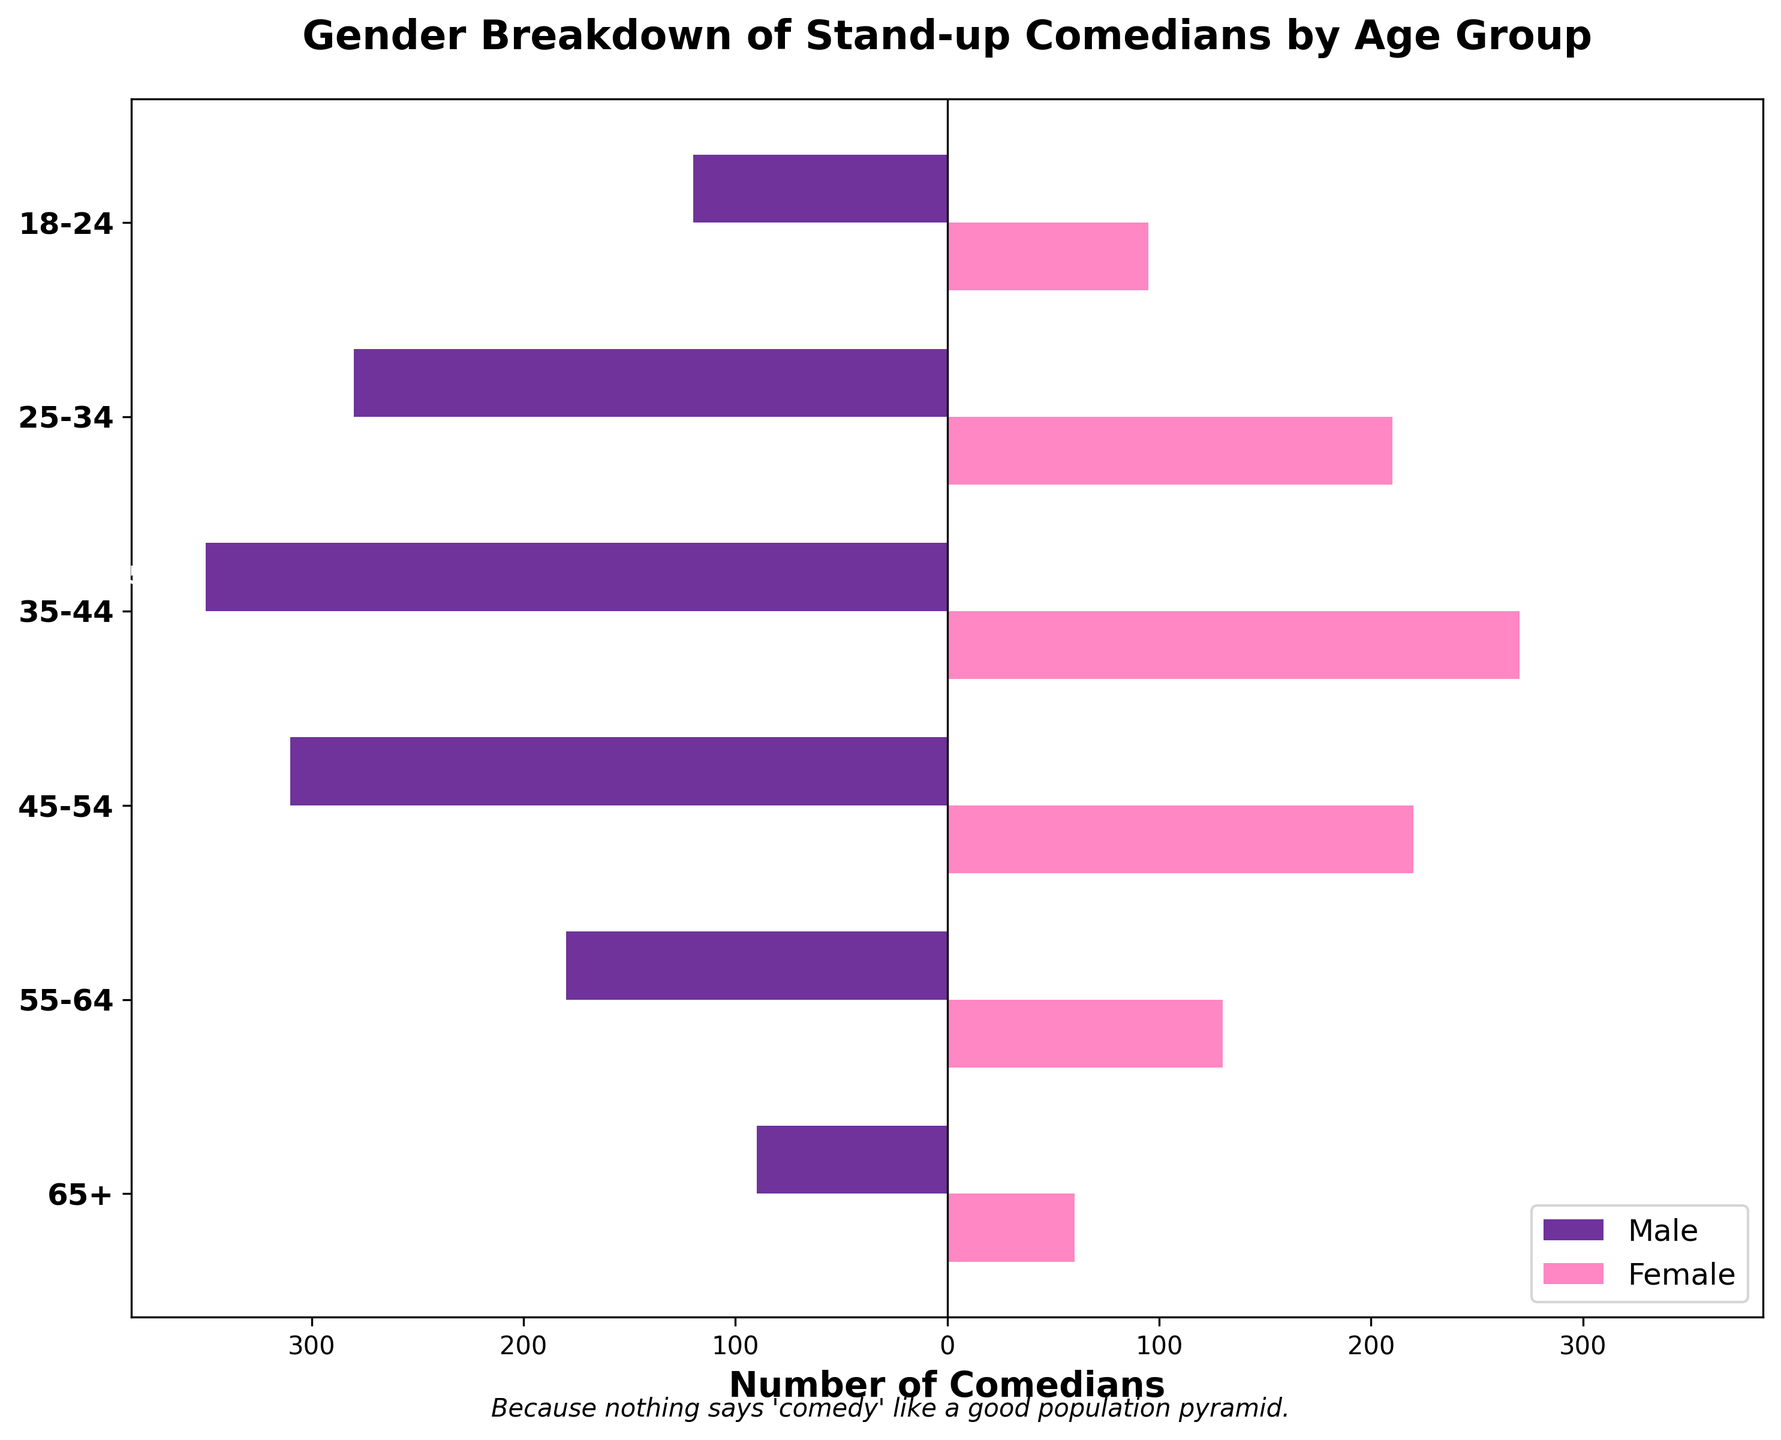What is the title of the figure? The title of the figure is usually located at the top of the chart and provides a summary of the information depicted. In this case, the title is written in bold and reads "Gender Breakdown of Stand-up Comedians by Age Group".
Answer: Gender Breakdown of Stand-up Comedians by Age Group What are the age groups included in the figure? The age groups are listed on the y-axis on the left side of the figure. They are arranged in descending order and include "18-24", "25-34", "35-44", "45-54", "55-64", and "65+".
Answer: 18-24, 25-34, 35-44, 45-54, 55-64, 65+ Which age group has the highest number of male comedians? By observing the male comedians' bars, which are colored in indigo and extend to the left side of the chart, the age group with the longest bar represents the highest number. The longest bar is in the "35-44" age group.
Answer: 35-44 What is the total number of comedians in the 18-24 age group? Sum up the numbers for male and female comedians in the 18-24 age group. There are 120 male comedians and 95 female comedians. Adding these gives 215 comedians in total.
Answer: 215 How many more male comedians are there than female comedians in the 45-54 age group? Find the difference between the number of male comedians (310) and female comedians (220) in the 45-54 age group. The difference is 310 - 220 = 90.
Answer: 90 What is the proportion of female comedians in the 35-44 age group compared to the total comedians in that group? First, find the total number of comedians in the 35-44 age group by adding males (350) and females (270), which gives 620. Then, calculate the proportion of female comedians as (270 / 620) * 100 ≈ 43.55%.
Answer: ~43.55% How does the number of comedians in the 65+ age group compare between males and females? Compare the lengths of the bars for the 65+ age group. The male comedians' bar is longer, representing 90 comedians, while the female comedians' bar represents 60 comedians. Thus, there are 30 fewer female comedians than male comedians.
Answer: 30 fewer Which gender has more comedians in the 25-34 age group, and by how much? Look at the bars for the 25-34 age group. There are 280 male comedians and 210 female comedians. Males outnumber females by 280 - 210 = 70.
Answer: Males by 70 In which age group is the gender disparity (the difference between males and females) the smallest? Calculate the gender disparity for each age group and find the smallest value. The differences are as follows: 18-24 (25), 25-34 (70), 35-44 (80), 45-54 (90), 55-64 (50), 65+ (30). The smallest difference is in the 18-24 age group.
Answer: 18-24 What humorous subtitle is added to the plot? Check the text usually located at the bottom of the plot, which is intended to add a touch of dry humor. It reads, "Because nothing says 'comedy' like a good population pyramid."
Answer: Because nothing says 'comedy' like a good population pyramid 